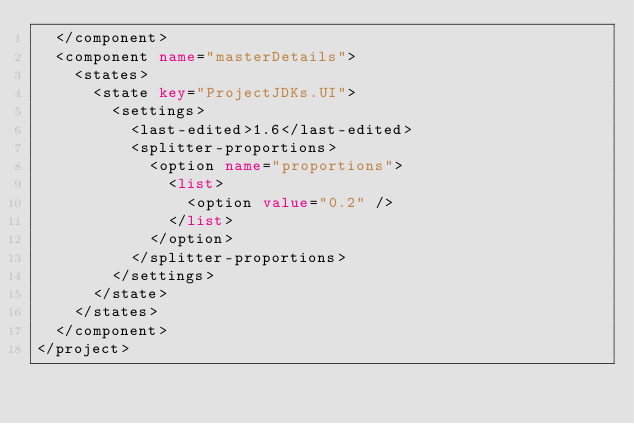<code> <loc_0><loc_0><loc_500><loc_500><_XML_>  </component>
  <component name="masterDetails">
    <states>
      <state key="ProjectJDKs.UI">
        <settings>
          <last-edited>1.6</last-edited>
          <splitter-proportions>
            <option name="proportions">
              <list>
                <option value="0.2" />
              </list>
            </option>
          </splitter-proportions>
        </settings>
      </state>
    </states>
  </component>
</project></code> 